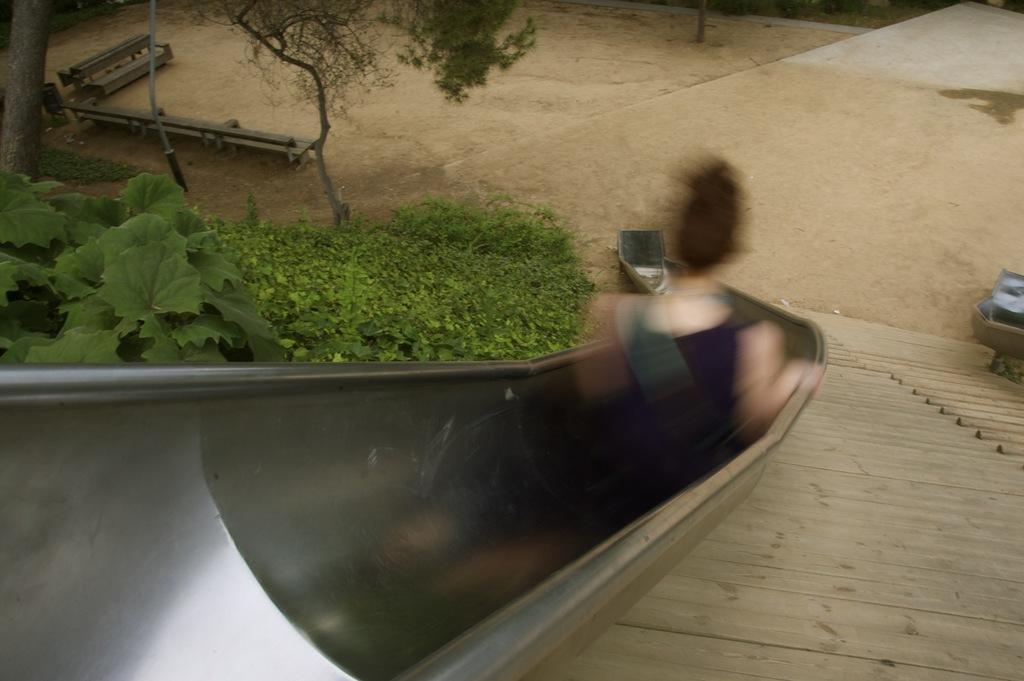Can you describe this image briefly? In this image I can see the person sitting on the slide. I can see the person is blurred. To the left I can see the plants, trees, benches and the table. In the background I can see the ground. 